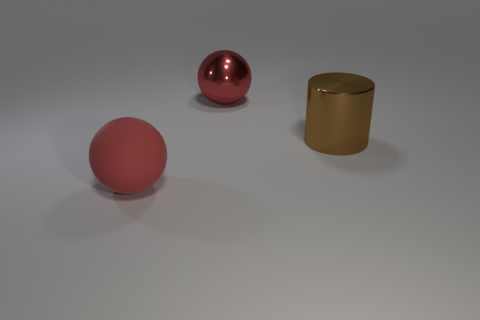Add 2 metal cylinders. How many objects exist? 5 Subtract all balls. How many objects are left? 1 Add 1 big red balls. How many big red balls exist? 3 Subtract 0 purple spheres. How many objects are left? 3 Subtract all small green metallic cubes. Subtract all metal cylinders. How many objects are left? 2 Add 2 large red shiny spheres. How many large red shiny spheres are left? 3 